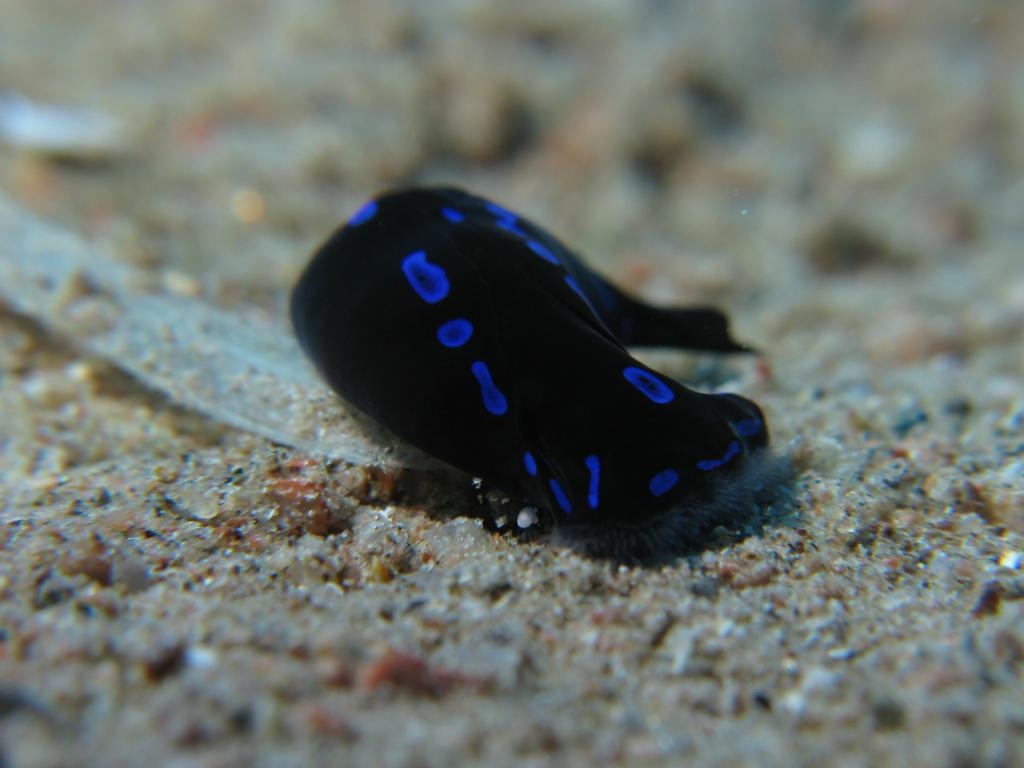What type of animal is in the image? There is a black and blue fish in the image. Where is the fish located? The fish is in the water. What is at the bottom of the water? There is sand at the bottom of the water. What type of instrument is the fish playing in the image? There is no instrument present in the image, and the fish is not playing any instrument. 